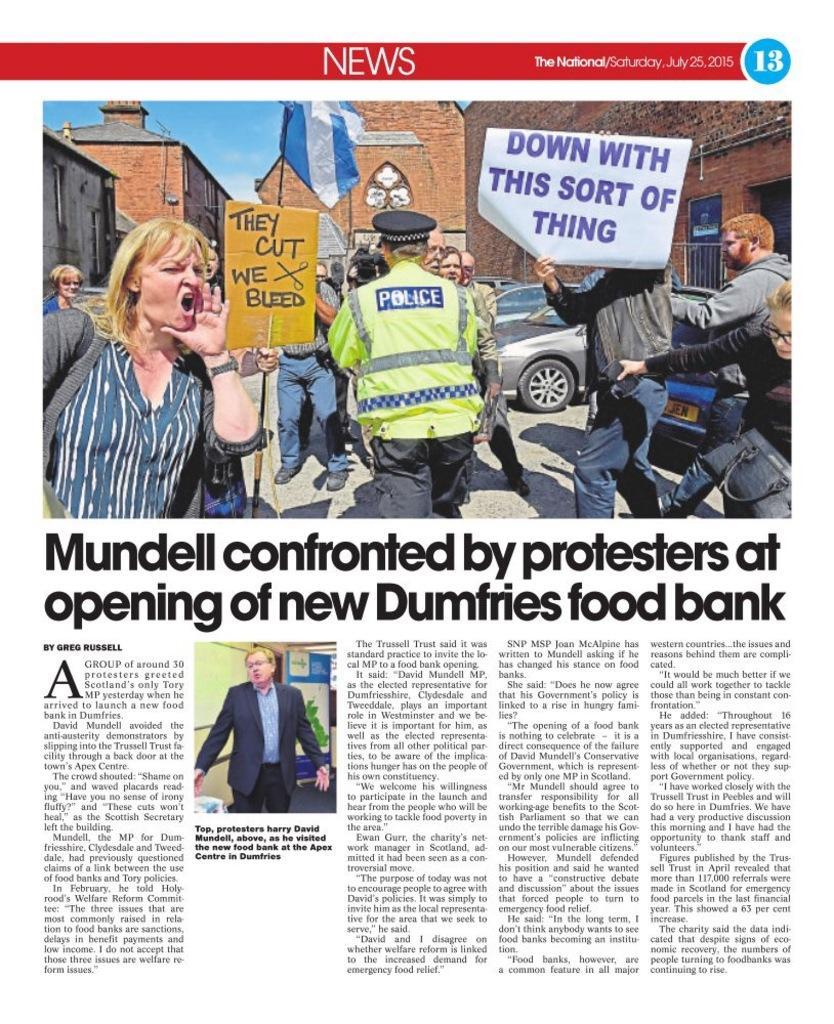Describe this image in one or two sentences. In this image it seems like it is a news article. In the article it looks like there is a protest going on, on the road. There are few people who are holding the placards while the other people are shouting. In the background there are buildings and cars. There is a man in the middle who is holding the flag. 